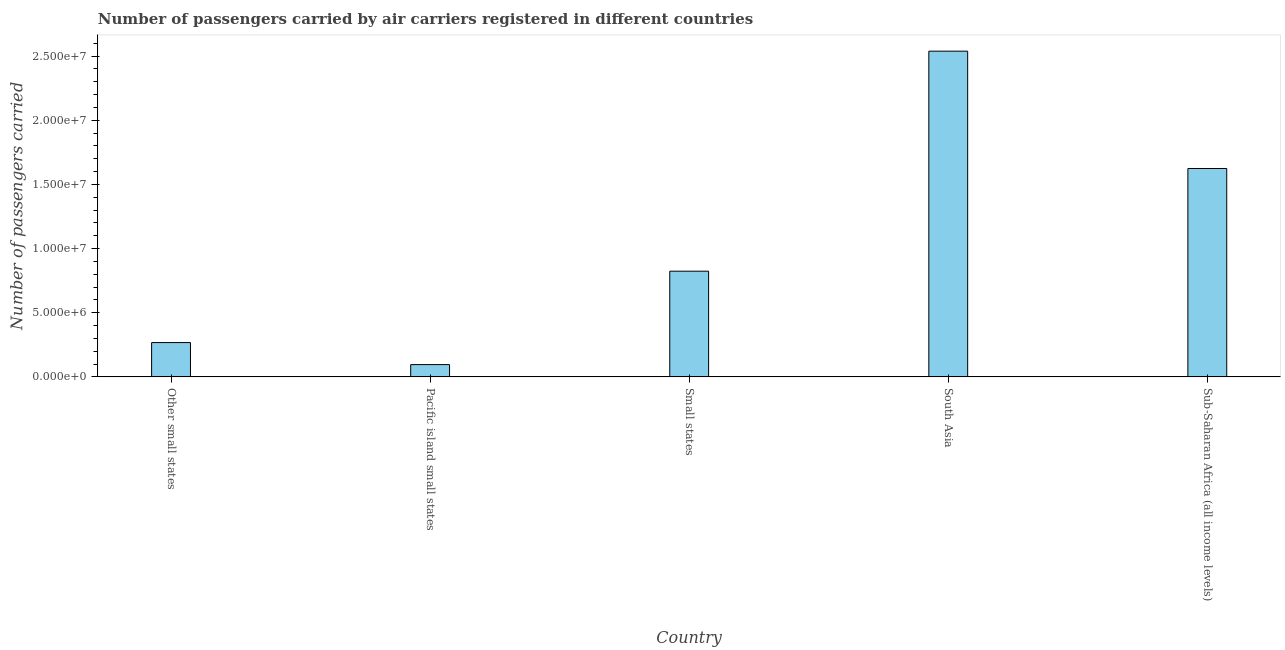What is the title of the graph?
Ensure brevity in your answer.  Number of passengers carried by air carriers registered in different countries. What is the label or title of the Y-axis?
Your answer should be compact. Number of passengers carried. What is the number of passengers carried in Pacific island small states?
Offer a very short reply. 9.57e+05. Across all countries, what is the maximum number of passengers carried?
Your answer should be very brief. 2.54e+07. Across all countries, what is the minimum number of passengers carried?
Give a very brief answer. 9.57e+05. In which country was the number of passengers carried minimum?
Offer a very short reply. Pacific island small states. What is the sum of the number of passengers carried?
Provide a succinct answer. 5.35e+07. What is the difference between the number of passengers carried in Pacific island small states and South Asia?
Make the answer very short. -2.44e+07. What is the average number of passengers carried per country?
Ensure brevity in your answer.  1.07e+07. What is the median number of passengers carried?
Provide a succinct answer. 8.24e+06. What is the ratio of the number of passengers carried in Other small states to that in Pacific island small states?
Your answer should be very brief. 2.79. What is the difference between the highest and the second highest number of passengers carried?
Offer a very short reply. 9.15e+06. Is the sum of the number of passengers carried in Pacific island small states and Small states greater than the maximum number of passengers carried across all countries?
Provide a short and direct response. No. What is the difference between the highest and the lowest number of passengers carried?
Give a very brief answer. 2.44e+07. In how many countries, is the number of passengers carried greater than the average number of passengers carried taken over all countries?
Provide a succinct answer. 2. How many bars are there?
Make the answer very short. 5. Are all the bars in the graph horizontal?
Your answer should be very brief. No. What is the difference between two consecutive major ticks on the Y-axis?
Give a very brief answer. 5.00e+06. What is the Number of passengers carried of Other small states?
Your answer should be compact. 2.67e+06. What is the Number of passengers carried of Pacific island small states?
Give a very brief answer. 9.57e+05. What is the Number of passengers carried of Small states?
Ensure brevity in your answer.  8.24e+06. What is the Number of passengers carried in South Asia?
Provide a succinct answer. 2.54e+07. What is the Number of passengers carried in Sub-Saharan Africa (all income levels)?
Offer a very short reply. 1.62e+07. What is the difference between the Number of passengers carried in Other small states and Pacific island small states?
Offer a terse response. 1.72e+06. What is the difference between the Number of passengers carried in Other small states and Small states?
Ensure brevity in your answer.  -5.56e+06. What is the difference between the Number of passengers carried in Other small states and South Asia?
Provide a succinct answer. -2.27e+07. What is the difference between the Number of passengers carried in Other small states and Sub-Saharan Africa (all income levels)?
Your response must be concise. -1.36e+07. What is the difference between the Number of passengers carried in Pacific island small states and Small states?
Make the answer very short. -7.28e+06. What is the difference between the Number of passengers carried in Pacific island small states and South Asia?
Make the answer very short. -2.44e+07. What is the difference between the Number of passengers carried in Pacific island small states and Sub-Saharan Africa (all income levels)?
Your response must be concise. -1.53e+07. What is the difference between the Number of passengers carried in Small states and South Asia?
Your response must be concise. -1.72e+07. What is the difference between the Number of passengers carried in Small states and Sub-Saharan Africa (all income levels)?
Provide a succinct answer. -8.00e+06. What is the difference between the Number of passengers carried in South Asia and Sub-Saharan Africa (all income levels)?
Give a very brief answer. 9.15e+06. What is the ratio of the Number of passengers carried in Other small states to that in Pacific island small states?
Your answer should be very brief. 2.79. What is the ratio of the Number of passengers carried in Other small states to that in Small states?
Offer a very short reply. 0.33. What is the ratio of the Number of passengers carried in Other small states to that in South Asia?
Your answer should be very brief. 0.1. What is the ratio of the Number of passengers carried in Other small states to that in Sub-Saharan Africa (all income levels)?
Your answer should be compact. 0.17. What is the ratio of the Number of passengers carried in Pacific island small states to that in Small states?
Give a very brief answer. 0.12. What is the ratio of the Number of passengers carried in Pacific island small states to that in South Asia?
Ensure brevity in your answer.  0.04. What is the ratio of the Number of passengers carried in Pacific island small states to that in Sub-Saharan Africa (all income levels)?
Your response must be concise. 0.06. What is the ratio of the Number of passengers carried in Small states to that in South Asia?
Keep it short and to the point. 0.32. What is the ratio of the Number of passengers carried in Small states to that in Sub-Saharan Africa (all income levels)?
Provide a short and direct response. 0.51. What is the ratio of the Number of passengers carried in South Asia to that in Sub-Saharan Africa (all income levels)?
Offer a very short reply. 1.56. 